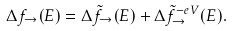<formula> <loc_0><loc_0><loc_500><loc_500>\Delta f _ { \rightarrow } ( E ) = \Delta \tilde { f } _ { \rightarrow } ( E ) + \Delta \tilde { f } _ { \rightarrow } ^ { - e V } ( E ) .</formula> 